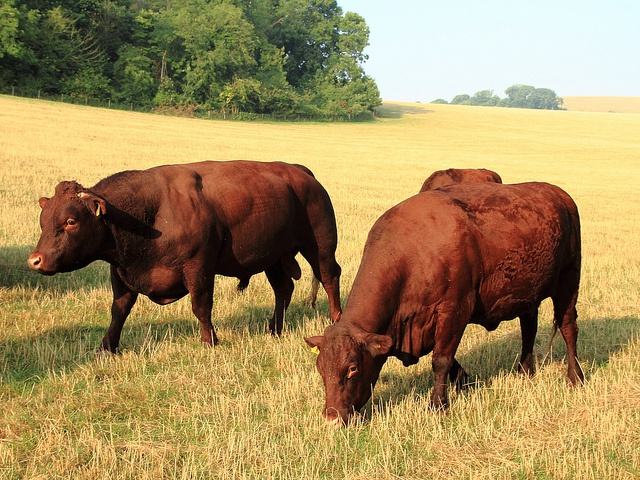Describe the objects in this image and their specific colors. I can see cow in darkgreen, black, maroon, and brown tones, cow in darkgreen, black, maroon, brown, and red tones, and cow in darkgreen, brown, maroon, and khaki tones in this image. 